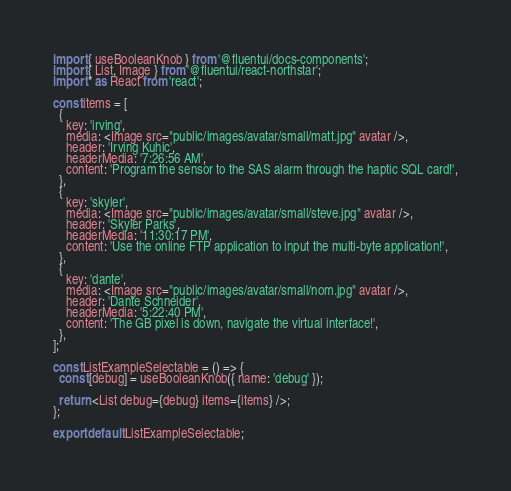<code> <loc_0><loc_0><loc_500><loc_500><_TypeScript_>import { useBooleanKnob } from '@fluentui/docs-components';
import { List, Image } from '@fluentui/react-northstar';
import * as React from 'react';

const items = [
  {
    key: 'irving',
    media: <Image src="public/images/avatar/small/matt.jpg" avatar />,
    header: 'Irving Kuhic',
    headerMedia: '7:26:56 AM',
    content: 'Program the sensor to the SAS alarm through the haptic SQL card!',
  },
  {
    key: 'skyler',
    media: <Image src="public/images/avatar/small/steve.jpg" avatar />,
    header: 'Skyler Parks',
    headerMedia: '11:30:17 PM',
    content: 'Use the online FTP application to input the multi-byte application!',
  },
  {
    key: 'dante',
    media: <Image src="public/images/avatar/small/nom.jpg" avatar />,
    header: 'Dante Schneider',
    headerMedia: '5:22:40 PM',
    content: 'The GB pixel is down, navigate the virtual interface!',
  },
];

const ListExampleSelectable = () => {
  const [debug] = useBooleanKnob({ name: 'debug' });

  return <List debug={debug} items={items} />;
};

export default ListExampleSelectable;
</code> 